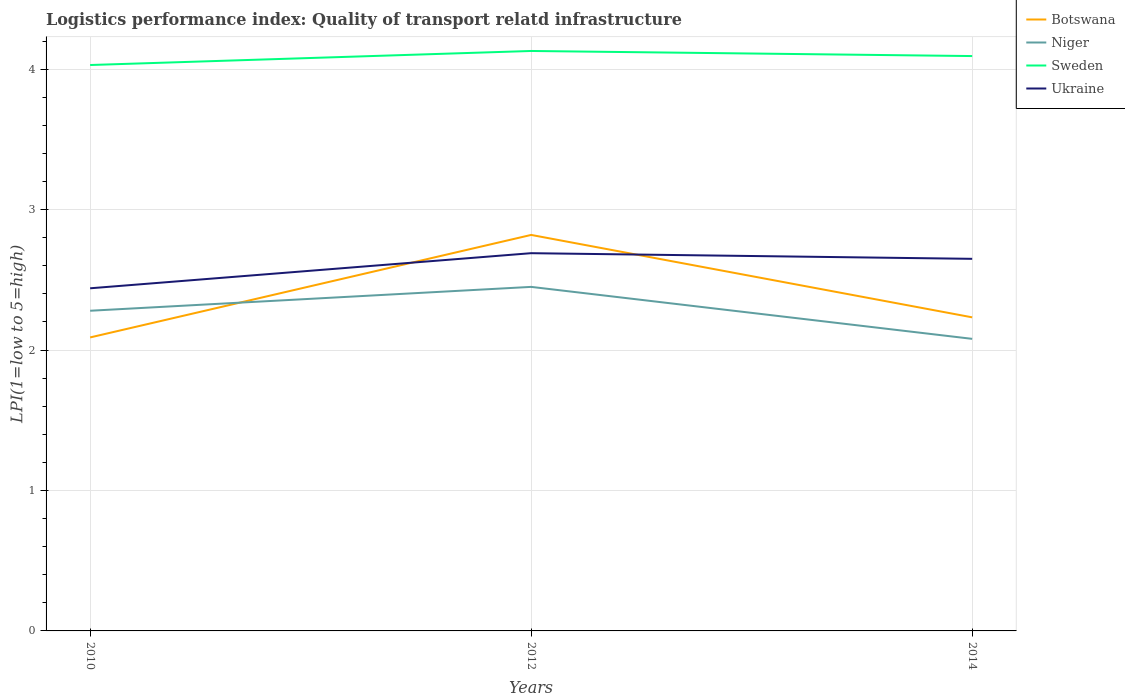How many different coloured lines are there?
Offer a very short reply. 4. Does the line corresponding to Ukraine intersect with the line corresponding to Sweden?
Make the answer very short. No. Is the number of lines equal to the number of legend labels?
Keep it short and to the point. Yes. Across all years, what is the maximum logistics performance index in Botswana?
Make the answer very short. 2.09. What is the total logistics performance index in Sweden in the graph?
Ensure brevity in your answer.  -0.06. Is the logistics performance index in Ukraine strictly greater than the logistics performance index in Sweden over the years?
Provide a succinct answer. Yes. How many lines are there?
Give a very brief answer. 4. Does the graph contain grids?
Ensure brevity in your answer.  Yes. What is the title of the graph?
Give a very brief answer. Logistics performance index: Quality of transport relatd infrastructure. What is the label or title of the Y-axis?
Give a very brief answer. LPI(1=low to 5=high). What is the LPI(1=low to 5=high) of Botswana in 2010?
Ensure brevity in your answer.  2.09. What is the LPI(1=low to 5=high) in Niger in 2010?
Keep it short and to the point. 2.28. What is the LPI(1=low to 5=high) of Sweden in 2010?
Offer a very short reply. 4.03. What is the LPI(1=low to 5=high) in Ukraine in 2010?
Your answer should be compact. 2.44. What is the LPI(1=low to 5=high) in Botswana in 2012?
Provide a short and direct response. 2.82. What is the LPI(1=low to 5=high) in Niger in 2012?
Make the answer very short. 2.45. What is the LPI(1=low to 5=high) in Sweden in 2012?
Your answer should be very brief. 4.13. What is the LPI(1=low to 5=high) of Ukraine in 2012?
Offer a terse response. 2.69. What is the LPI(1=low to 5=high) in Botswana in 2014?
Keep it short and to the point. 2.23. What is the LPI(1=low to 5=high) in Niger in 2014?
Your response must be concise. 2.08. What is the LPI(1=low to 5=high) of Sweden in 2014?
Give a very brief answer. 4.09. What is the LPI(1=low to 5=high) of Ukraine in 2014?
Provide a succinct answer. 2.65. Across all years, what is the maximum LPI(1=low to 5=high) in Botswana?
Offer a terse response. 2.82. Across all years, what is the maximum LPI(1=low to 5=high) of Niger?
Provide a succinct answer. 2.45. Across all years, what is the maximum LPI(1=low to 5=high) of Sweden?
Keep it short and to the point. 4.13. Across all years, what is the maximum LPI(1=low to 5=high) of Ukraine?
Your answer should be very brief. 2.69. Across all years, what is the minimum LPI(1=low to 5=high) of Botswana?
Keep it short and to the point. 2.09. Across all years, what is the minimum LPI(1=low to 5=high) of Niger?
Provide a short and direct response. 2.08. Across all years, what is the minimum LPI(1=low to 5=high) of Sweden?
Offer a terse response. 4.03. Across all years, what is the minimum LPI(1=low to 5=high) in Ukraine?
Make the answer very short. 2.44. What is the total LPI(1=low to 5=high) in Botswana in the graph?
Offer a terse response. 7.14. What is the total LPI(1=low to 5=high) of Niger in the graph?
Make the answer very short. 6.81. What is the total LPI(1=low to 5=high) in Sweden in the graph?
Provide a short and direct response. 12.25. What is the total LPI(1=low to 5=high) of Ukraine in the graph?
Make the answer very short. 7.78. What is the difference between the LPI(1=low to 5=high) of Botswana in 2010 and that in 2012?
Give a very brief answer. -0.73. What is the difference between the LPI(1=low to 5=high) of Niger in 2010 and that in 2012?
Offer a very short reply. -0.17. What is the difference between the LPI(1=low to 5=high) of Sweden in 2010 and that in 2012?
Ensure brevity in your answer.  -0.1. What is the difference between the LPI(1=low to 5=high) of Botswana in 2010 and that in 2014?
Your answer should be very brief. -0.14. What is the difference between the LPI(1=low to 5=high) in Niger in 2010 and that in 2014?
Keep it short and to the point. 0.2. What is the difference between the LPI(1=low to 5=high) of Sweden in 2010 and that in 2014?
Make the answer very short. -0.06. What is the difference between the LPI(1=low to 5=high) in Ukraine in 2010 and that in 2014?
Your answer should be very brief. -0.21. What is the difference between the LPI(1=low to 5=high) in Botswana in 2012 and that in 2014?
Make the answer very short. 0.59. What is the difference between the LPI(1=low to 5=high) of Niger in 2012 and that in 2014?
Ensure brevity in your answer.  0.37. What is the difference between the LPI(1=low to 5=high) of Sweden in 2012 and that in 2014?
Offer a terse response. 0.04. What is the difference between the LPI(1=low to 5=high) of Ukraine in 2012 and that in 2014?
Make the answer very short. 0.04. What is the difference between the LPI(1=low to 5=high) in Botswana in 2010 and the LPI(1=low to 5=high) in Niger in 2012?
Make the answer very short. -0.36. What is the difference between the LPI(1=low to 5=high) of Botswana in 2010 and the LPI(1=low to 5=high) of Sweden in 2012?
Provide a succinct answer. -2.04. What is the difference between the LPI(1=low to 5=high) of Niger in 2010 and the LPI(1=low to 5=high) of Sweden in 2012?
Keep it short and to the point. -1.85. What is the difference between the LPI(1=low to 5=high) in Niger in 2010 and the LPI(1=low to 5=high) in Ukraine in 2012?
Offer a very short reply. -0.41. What is the difference between the LPI(1=low to 5=high) in Sweden in 2010 and the LPI(1=low to 5=high) in Ukraine in 2012?
Your answer should be compact. 1.34. What is the difference between the LPI(1=low to 5=high) of Botswana in 2010 and the LPI(1=low to 5=high) of Niger in 2014?
Offer a very short reply. 0.01. What is the difference between the LPI(1=low to 5=high) of Botswana in 2010 and the LPI(1=low to 5=high) of Sweden in 2014?
Your response must be concise. -2. What is the difference between the LPI(1=low to 5=high) of Botswana in 2010 and the LPI(1=low to 5=high) of Ukraine in 2014?
Provide a succinct answer. -0.56. What is the difference between the LPI(1=low to 5=high) of Niger in 2010 and the LPI(1=low to 5=high) of Sweden in 2014?
Provide a succinct answer. -1.81. What is the difference between the LPI(1=low to 5=high) in Niger in 2010 and the LPI(1=low to 5=high) in Ukraine in 2014?
Make the answer very short. -0.37. What is the difference between the LPI(1=low to 5=high) in Sweden in 2010 and the LPI(1=low to 5=high) in Ukraine in 2014?
Your answer should be compact. 1.38. What is the difference between the LPI(1=low to 5=high) in Botswana in 2012 and the LPI(1=low to 5=high) in Niger in 2014?
Your response must be concise. 0.74. What is the difference between the LPI(1=low to 5=high) of Botswana in 2012 and the LPI(1=low to 5=high) of Sweden in 2014?
Give a very brief answer. -1.27. What is the difference between the LPI(1=low to 5=high) in Botswana in 2012 and the LPI(1=low to 5=high) in Ukraine in 2014?
Your answer should be very brief. 0.17. What is the difference between the LPI(1=low to 5=high) of Niger in 2012 and the LPI(1=low to 5=high) of Sweden in 2014?
Provide a succinct answer. -1.64. What is the difference between the LPI(1=low to 5=high) of Niger in 2012 and the LPI(1=low to 5=high) of Ukraine in 2014?
Your answer should be compact. -0.2. What is the difference between the LPI(1=low to 5=high) of Sweden in 2012 and the LPI(1=low to 5=high) of Ukraine in 2014?
Your answer should be very brief. 1.48. What is the average LPI(1=low to 5=high) in Botswana per year?
Provide a short and direct response. 2.38. What is the average LPI(1=low to 5=high) of Niger per year?
Provide a short and direct response. 2.27. What is the average LPI(1=low to 5=high) in Sweden per year?
Make the answer very short. 4.08. What is the average LPI(1=low to 5=high) in Ukraine per year?
Make the answer very short. 2.59. In the year 2010, what is the difference between the LPI(1=low to 5=high) in Botswana and LPI(1=low to 5=high) in Niger?
Offer a very short reply. -0.19. In the year 2010, what is the difference between the LPI(1=low to 5=high) in Botswana and LPI(1=low to 5=high) in Sweden?
Your response must be concise. -1.94. In the year 2010, what is the difference between the LPI(1=low to 5=high) in Botswana and LPI(1=low to 5=high) in Ukraine?
Offer a terse response. -0.35. In the year 2010, what is the difference between the LPI(1=low to 5=high) in Niger and LPI(1=low to 5=high) in Sweden?
Provide a short and direct response. -1.75. In the year 2010, what is the difference between the LPI(1=low to 5=high) in Niger and LPI(1=low to 5=high) in Ukraine?
Provide a short and direct response. -0.16. In the year 2010, what is the difference between the LPI(1=low to 5=high) of Sweden and LPI(1=low to 5=high) of Ukraine?
Provide a succinct answer. 1.59. In the year 2012, what is the difference between the LPI(1=low to 5=high) of Botswana and LPI(1=low to 5=high) of Niger?
Ensure brevity in your answer.  0.37. In the year 2012, what is the difference between the LPI(1=low to 5=high) of Botswana and LPI(1=low to 5=high) of Sweden?
Provide a succinct answer. -1.31. In the year 2012, what is the difference between the LPI(1=low to 5=high) of Botswana and LPI(1=low to 5=high) of Ukraine?
Provide a succinct answer. 0.13. In the year 2012, what is the difference between the LPI(1=low to 5=high) of Niger and LPI(1=low to 5=high) of Sweden?
Keep it short and to the point. -1.68. In the year 2012, what is the difference between the LPI(1=low to 5=high) in Niger and LPI(1=low to 5=high) in Ukraine?
Ensure brevity in your answer.  -0.24. In the year 2012, what is the difference between the LPI(1=low to 5=high) of Sweden and LPI(1=low to 5=high) of Ukraine?
Your answer should be very brief. 1.44. In the year 2014, what is the difference between the LPI(1=low to 5=high) in Botswana and LPI(1=low to 5=high) in Niger?
Offer a terse response. 0.15. In the year 2014, what is the difference between the LPI(1=low to 5=high) of Botswana and LPI(1=low to 5=high) of Sweden?
Keep it short and to the point. -1.86. In the year 2014, what is the difference between the LPI(1=low to 5=high) in Botswana and LPI(1=low to 5=high) in Ukraine?
Give a very brief answer. -0.42. In the year 2014, what is the difference between the LPI(1=low to 5=high) in Niger and LPI(1=low to 5=high) in Sweden?
Provide a short and direct response. -2.01. In the year 2014, what is the difference between the LPI(1=low to 5=high) in Niger and LPI(1=low to 5=high) in Ukraine?
Give a very brief answer. -0.57. In the year 2014, what is the difference between the LPI(1=low to 5=high) in Sweden and LPI(1=low to 5=high) in Ukraine?
Make the answer very short. 1.44. What is the ratio of the LPI(1=low to 5=high) in Botswana in 2010 to that in 2012?
Offer a terse response. 0.74. What is the ratio of the LPI(1=low to 5=high) of Niger in 2010 to that in 2012?
Your answer should be compact. 0.93. What is the ratio of the LPI(1=low to 5=high) of Sweden in 2010 to that in 2012?
Your answer should be very brief. 0.98. What is the ratio of the LPI(1=low to 5=high) in Ukraine in 2010 to that in 2012?
Make the answer very short. 0.91. What is the ratio of the LPI(1=low to 5=high) of Botswana in 2010 to that in 2014?
Keep it short and to the point. 0.94. What is the ratio of the LPI(1=low to 5=high) in Niger in 2010 to that in 2014?
Offer a terse response. 1.1. What is the ratio of the LPI(1=low to 5=high) of Sweden in 2010 to that in 2014?
Provide a short and direct response. 0.98. What is the ratio of the LPI(1=low to 5=high) in Ukraine in 2010 to that in 2014?
Ensure brevity in your answer.  0.92. What is the ratio of the LPI(1=low to 5=high) of Botswana in 2012 to that in 2014?
Offer a terse response. 1.26. What is the ratio of the LPI(1=low to 5=high) of Niger in 2012 to that in 2014?
Make the answer very short. 1.18. What is the ratio of the LPI(1=low to 5=high) of Sweden in 2012 to that in 2014?
Your answer should be compact. 1.01. What is the ratio of the LPI(1=low to 5=high) in Ukraine in 2012 to that in 2014?
Give a very brief answer. 1.02. What is the difference between the highest and the second highest LPI(1=low to 5=high) of Botswana?
Provide a succinct answer. 0.59. What is the difference between the highest and the second highest LPI(1=low to 5=high) in Niger?
Keep it short and to the point. 0.17. What is the difference between the highest and the second highest LPI(1=low to 5=high) in Sweden?
Make the answer very short. 0.04. What is the difference between the highest and the second highest LPI(1=low to 5=high) of Ukraine?
Provide a short and direct response. 0.04. What is the difference between the highest and the lowest LPI(1=low to 5=high) of Botswana?
Provide a short and direct response. 0.73. What is the difference between the highest and the lowest LPI(1=low to 5=high) of Niger?
Make the answer very short. 0.37. 